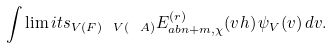Convert formula to latex. <formula><loc_0><loc_0><loc_500><loc_500>\int \lim i t s _ { V ( F ) \ V ( { \ A } ) } E _ { a b n + m , \chi } ^ { ( r ) } ( v h ) \, \psi _ { V } ( v ) \, d v .</formula> 